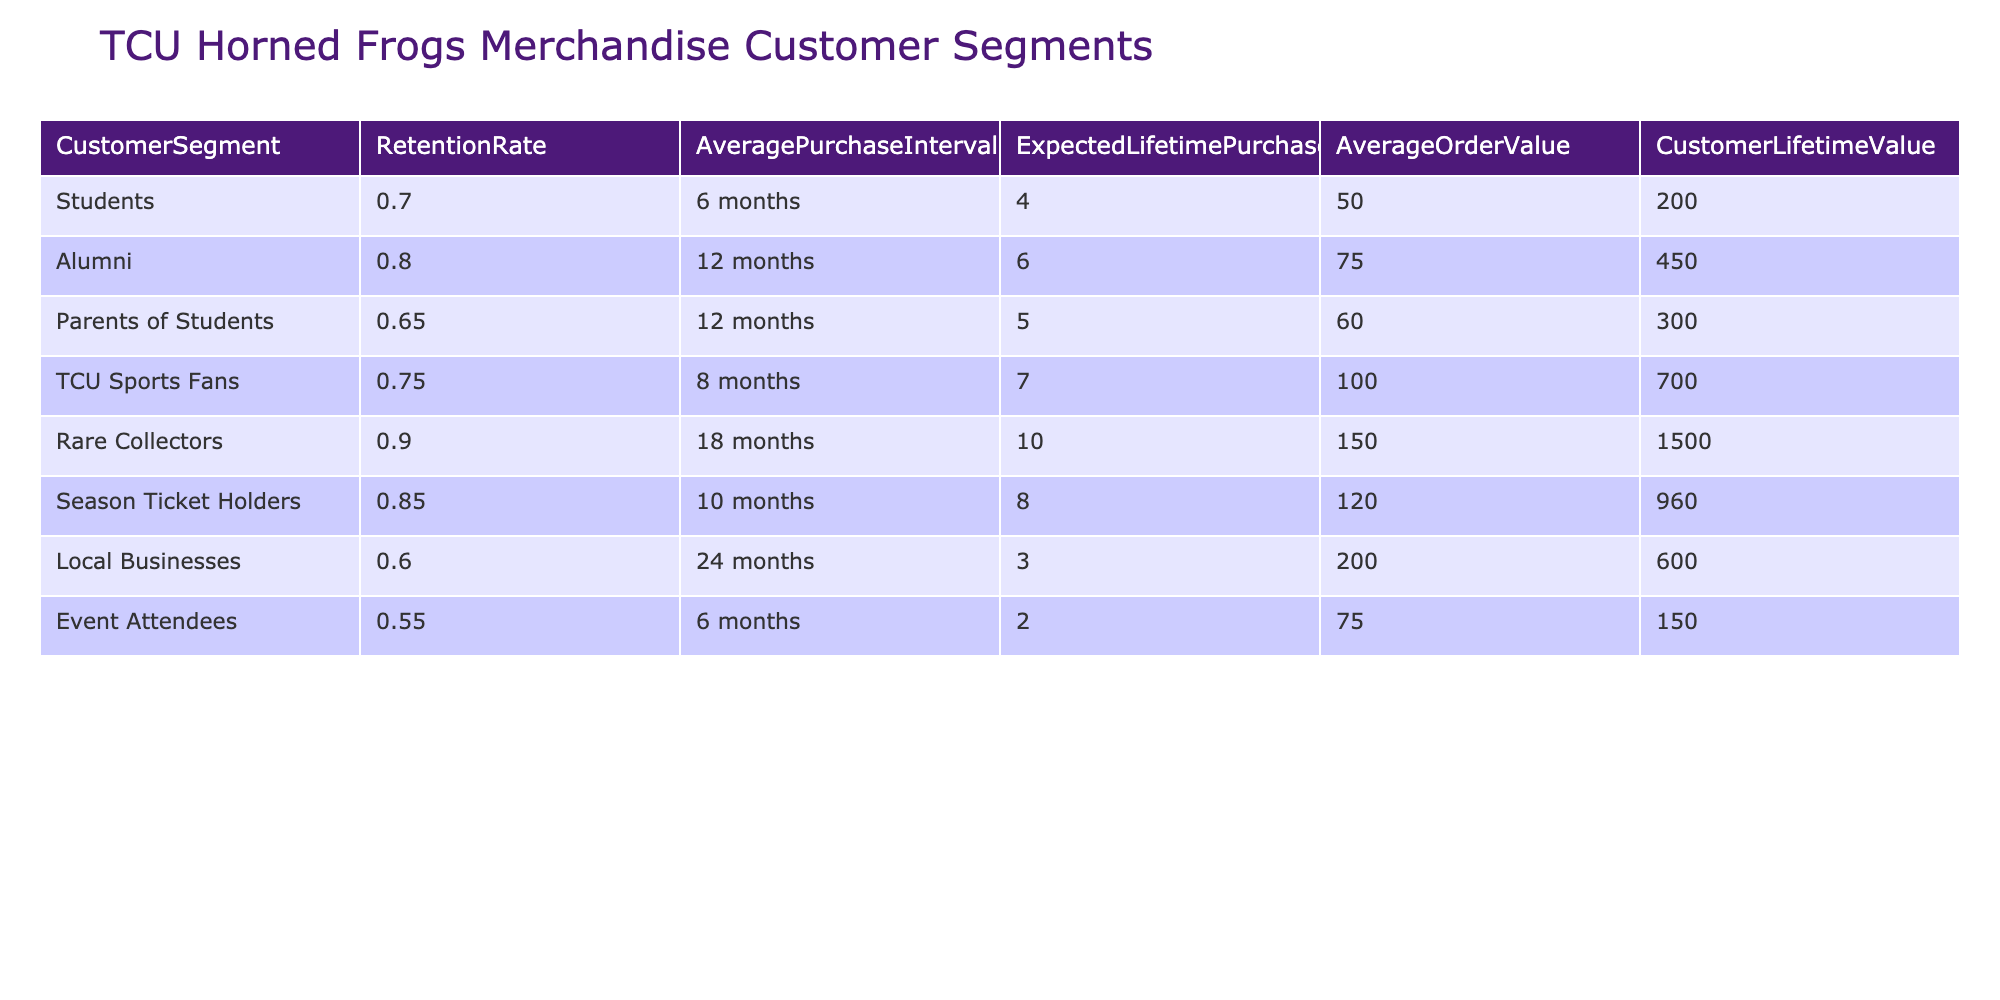What is the customer retention rate for Rare Collectors? The table shows that the retention rate for Rare Collectors is listed under the "RetentionRate" column for that specific segment. It states a retention rate of 0.90.
Answer: 0.90 Which customer segment has the highest customer lifetime value? To find the highest customer lifetime value, we can compare the values in the "CustomerLifetimeValue" column. The maximum value observed is 1500.00, which corresponds to the Rare Collectors segment.
Answer: Rare Collectors What is the average order value of Local Businesses? The average order value for Local Businesses can be directly found in the "AverageOrderValue" column. It is stated as 200.00.
Answer: 200.00 How many expected lifetime purchases do Season Ticket Holders have? The expected lifetime purchases for Season Ticket Holders can be found in the "ExpectedLifetimePurchases" column. It shows a value of 8.
Answer: 8 Do Events Attendees have a higher retention rate than Parents of Students? To compare, we look at the "RetentionRate" for both segments. Event Attendees have a rate of 0.55 while Parents of Students have a rate of 0.65. Since 0.55 is less than 0.65, the statement is false.
Answer: No What is the difference in average purchase intervals between Alumni and TCU Sports Fans? The "AveragePurchaseInterval" for Alumni is 12 months and for TCU Sports Fans it is 8 months. The difference is 12 - 8 = 4 months.
Answer: 4 months Which segments have a retention rate greater than 0.75? We need to filter the retention rates from the table: Rare Collectors (0.90), Season Ticket Holders (0.85), and Alumni (0.80) all exceed 0.75.
Answer: Rare Collectors, Season Ticket Holders, Alumni What is the average customer lifetime value for the segments with a retention rate below 0.70? We identify the segments with a retention rate below 0.70: Parents of Students (300.00), Local Businesses (600.00), and Event Attendees (150.00). The average is calculated as (300 + 600 + 150) / 3 = 350.
Answer: 350.00 Which customer segment has the shortest average purchase interval? The "AveragePurchaseInterval" for each segment is compared, and Event Attendees have the shortest interval at 6 months.
Answer: Event Attendees 